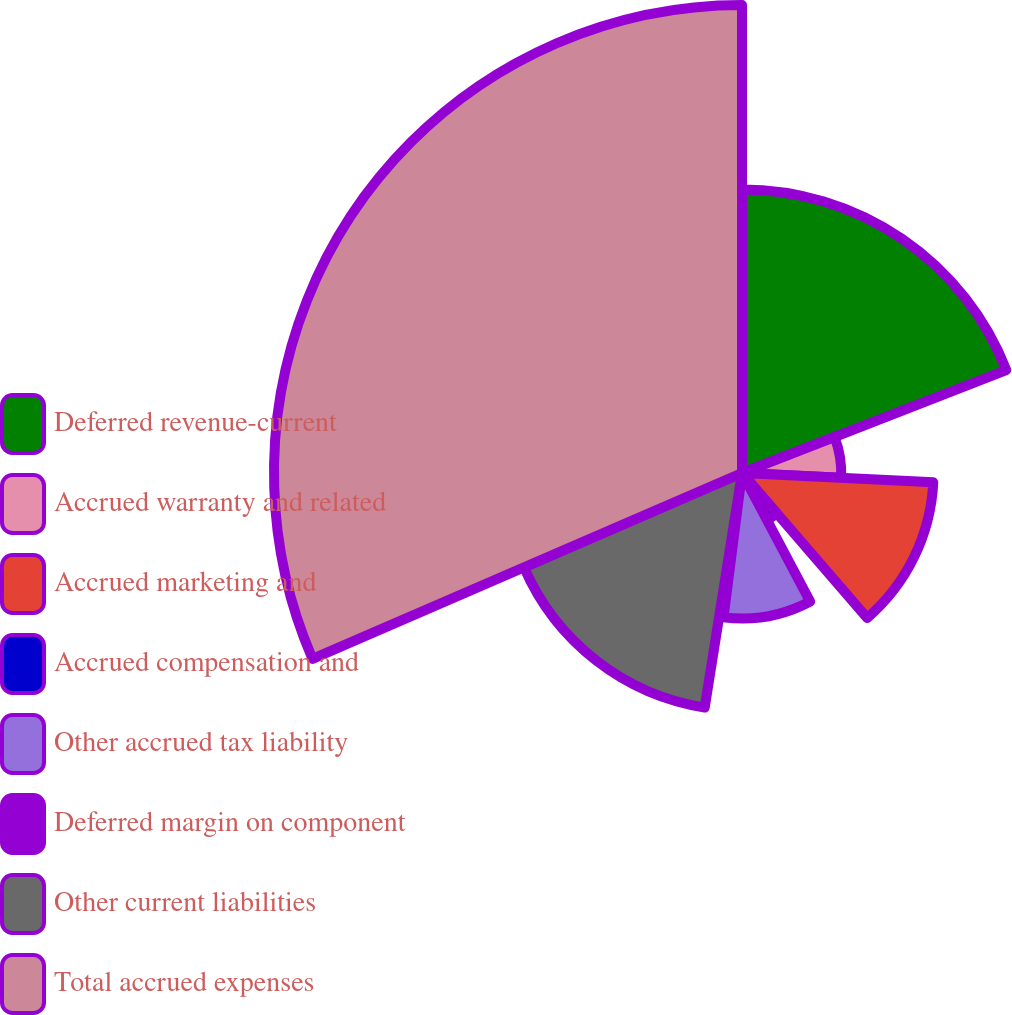<chart> <loc_0><loc_0><loc_500><loc_500><pie_chart><fcel>Deferred revenue-current<fcel>Accrued warranty and related<fcel>Accrued marketing and<fcel>Accrued compensation and<fcel>Other accrued tax liability<fcel>Deferred margin on component<fcel>Other current liabilities<fcel>Total accrued expenses<nl><fcel>19.09%<fcel>6.68%<fcel>12.89%<fcel>3.58%<fcel>9.79%<fcel>0.48%<fcel>15.99%<fcel>31.5%<nl></chart> 